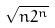Convert formula to latex. <formula><loc_0><loc_0><loc_500><loc_500>\sqrt { n 2 ^ { n } }</formula> 